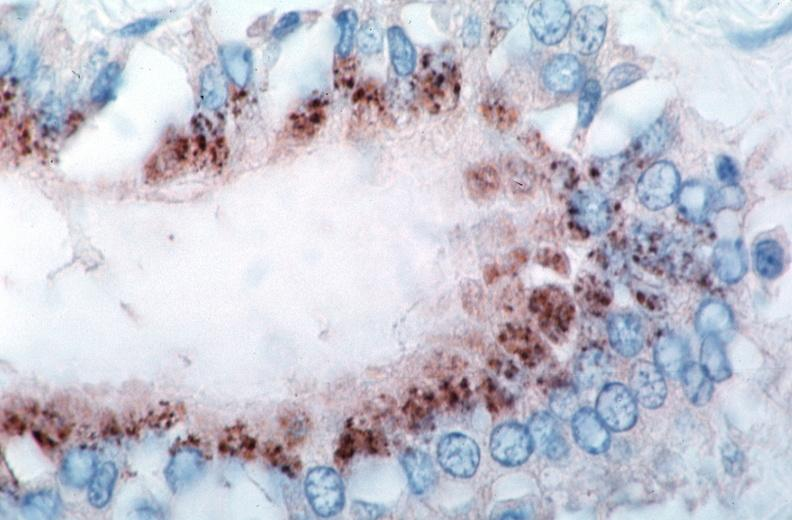s atherosclerosis present?
Answer the question using a single word or phrase. No 